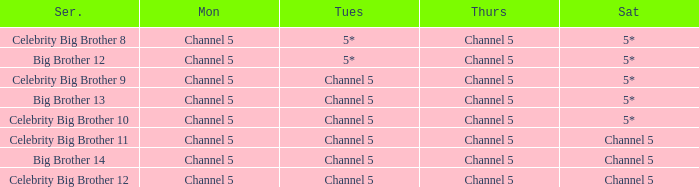Which Tuesday does big brother 12 air? 5*. 